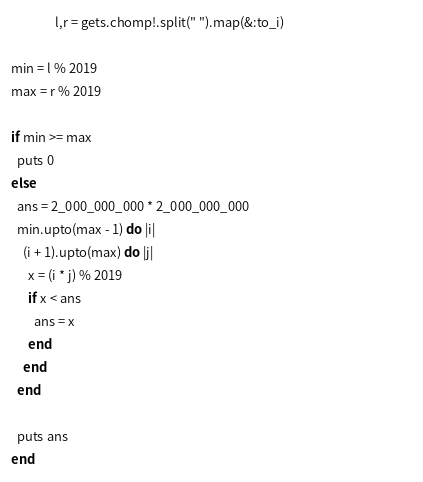<code> <loc_0><loc_0><loc_500><loc_500><_Ruby_>               l,r = gets.chomp!.split(" ").map(&:to_i)                                            
                                                                     
min = l % 2019                                                                      
max = r % 2019                                                                      
                                                                                    
if min >= max                                                                       
  puts 0                                                                            
else                                                                                
  ans = 2_000_000_000 * 2_000_000_000                                               
  min.upto(max - 1) do |i|                                                          
    (i + 1).upto(max) do |j|                                                        
      x = (i * j) % 2019                                                            
      if x < ans                                                                    
        ans = x                                                                     
      end                                                                           
    end                                                                             
  end                                                                               
                                                                                    
  puts ans                                                                          
end       </code> 